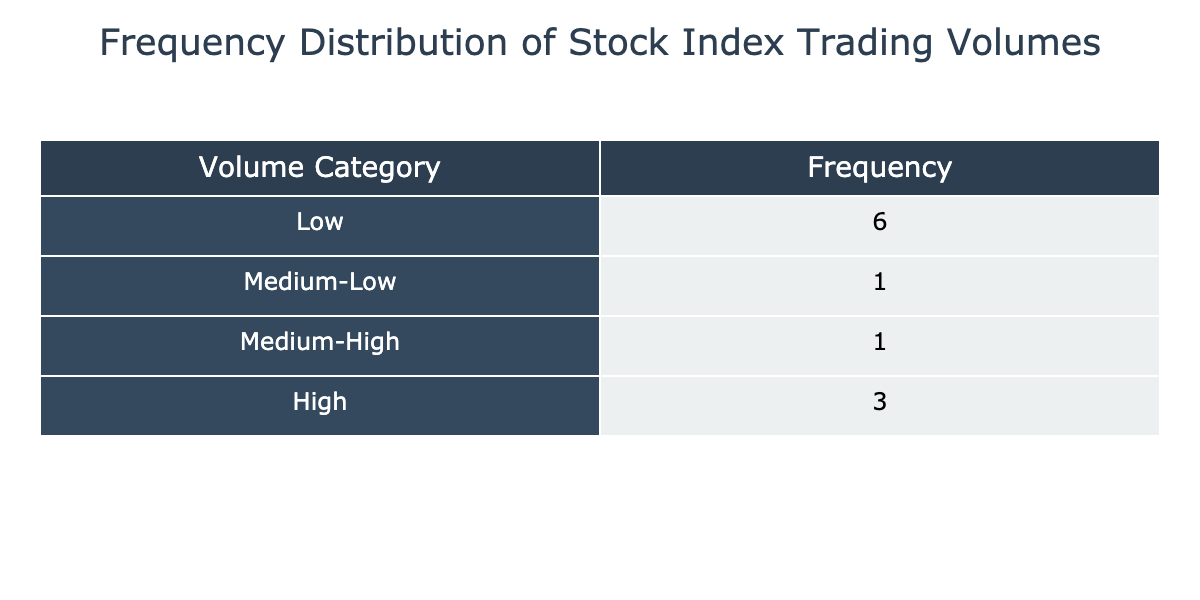What is the frequency of the 'Medium-Low' trading volume category? The 'Medium-Low' category is highlighted in the table and shows the count of indices that fall into that trading volume range. By checking the frequency for the 'Medium-Low' category, we find it corresponds to 4 indices.
Answer: 4 Which trading volume category has the highest frequency? Upon examining the table, we can compare the frequencies of each category. The 'Low' category has the highest frequency, as it corresponds to 5 indices.
Answer: Low What is the average trading volume of the indices classified under 'High'? We can determine the average trading volume by identifying the indices in the 'High' category, which includes the S&P 500 and Shanghai Composite. Adding their volumes (900 + 800 = 1700) gives us a total of 1700 million. Since there are 2 indices in this category, the average is 1700 / 2 = 850 million.
Answer: 850 million Is there any trading volume category with no indices? By reviewing the frequencies in the table, we see that all categories, 'Low', 'Medium-Low', 'Medium-High', and 'High', have indices in them. Therefore, there is no trading volume category without any indices.
Answer: No How many indices have an average trading volume lower than 400 million? We need to identify which indices fall below the 400 million mark from the table. The indices with trading volumes of 350, 300, and 250 million fall below this threshold. Specifically, these values correspond to 4 indices, which we count from the 'Low' and 'Medium-Low' categories.
Answer: 4 